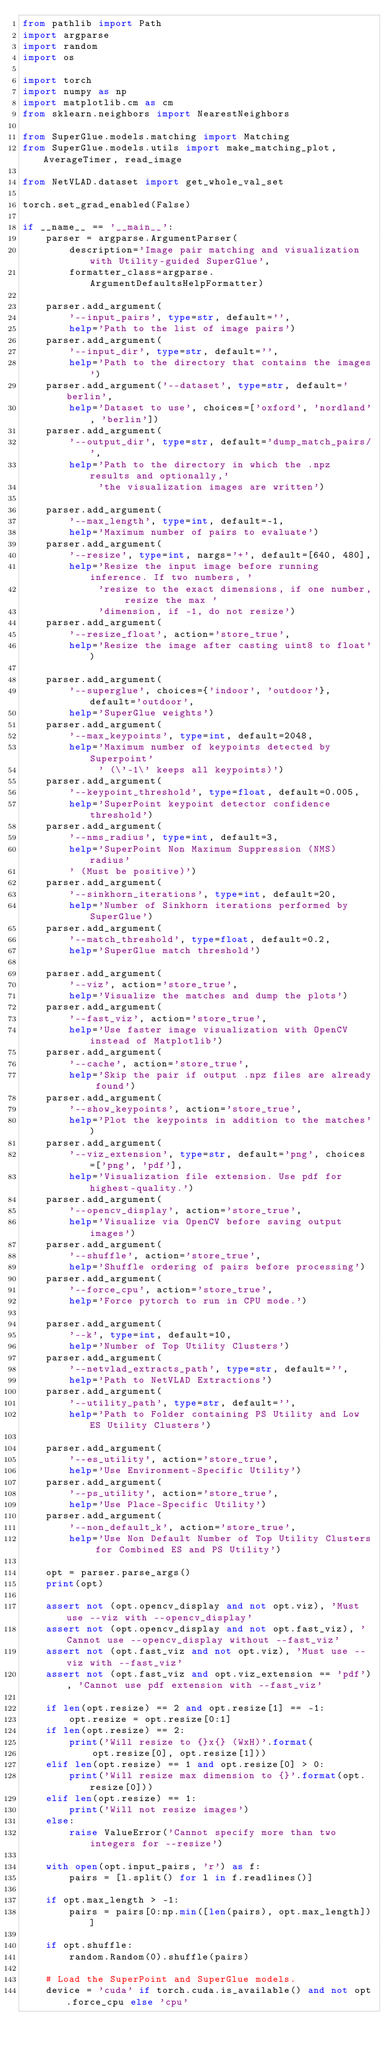Convert code to text. <code><loc_0><loc_0><loc_500><loc_500><_Python_>from pathlib import Path
import argparse
import random
import os

import torch
import numpy as np
import matplotlib.cm as cm
from sklearn.neighbors import NearestNeighbors

from SuperGlue.models.matching import Matching
from SuperGlue.models.utils import make_matching_plot, AverageTimer, read_image

from NetVLAD.dataset import get_whole_val_set

torch.set_grad_enabled(False)

if __name__ == '__main__':
    parser = argparse.ArgumentParser(
        description='Image pair matching and visualization with Utility-guided SuperGlue',
        formatter_class=argparse.ArgumentDefaultsHelpFormatter)

    parser.add_argument(
        '--input_pairs', type=str, default='',
        help='Path to the list of image pairs')
    parser.add_argument(
        '--input_dir', type=str, default='',
        help='Path to the directory that contains the images')
    parser.add_argument('--dataset', type=str, default='berlin', 
        help='Dataset to use', choices=['oxford', 'nordland', 'berlin'])
    parser.add_argument(
        '--output_dir', type=str, default='dump_match_pairs/',
        help='Path to the directory in which the .npz results and optionally,'
             'the visualization images are written')

    parser.add_argument(
        '--max_length', type=int, default=-1,
        help='Maximum number of pairs to evaluate')
    parser.add_argument(
        '--resize', type=int, nargs='+', default=[640, 480],
        help='Resize the input image before running inference. If two numbers, '
             'resize to the exact dimensions, if one number, resize the max '
             'dimension, if -1, do not resize')
    parser.add_argument(
        '--resize_float', action='store_true',
        help='Resize the image after casting uint8 to float')

    parser.add_argument(
        '--superglue', choices={'indoor', 'outdoor'}, default='outdoor',
        help='SuperGlue weights')
    parser.add_argument(
        '--max_keypoints', type=int, default=2048,
        help='Maximum number of keypoints detected by Superpoint'
             ' (\'-1\' keeps all keypoints)')
    parser.add_argument(
        '--keypoint_threshold', type=float, default=0.005,
        help='SuperPoint keypoint detector confidence threshold')
    parser.add_argument(
        '--nms_radius', type=int, default=3,
        help='SuperPoint Non Maximum Suppression (NMS) radius'
        ' (Must be positive)')
    parser.add_argument(
        '--sinkhorn_iterations', type=int, default=20,
        help='Number of Sinkhorn iterations performed by SuperGlue')
    parser.add_argument(
        '--match_threshold', type=float, default=0.2,
        help='SuperGlue match threshold')

    parser.add_argument(
        '--viz', action='store_true',
        help='Visualize the matches and dump the plots')
    parser.add_argument(
        '--fast_viz', action='store_true',
        help='Use faster image visualization with OpenCV instead of Matplotlib')
    parser.add_argument(
        '--cache', action='store_true',
        help='Skip the pair if output .npz files are already found')
    parser.add_argument(
        '--show_keypoints', action='store_true',
        help='Plot the keypoints in addition to the matches')
    parser.add_argument(
        '--viz_extension', type=str, default='png', choices=['png', 'pdf'],
        help='Visualization file extension. Use pdf for highest-quality.')
    parser.add_argument(
        '--opencv_display', action='store_true',
        help='Visualize via OpenCV before saving output images')
    parser.add_argument(
        '--shuffle', action='store_true',
        help='Shuffle ordering of pairs before processing')
    parser.add_argument(
        '--force_cpu', action='store_true',
        help='Force pytorch to run in CPU mode.')

    parser.add_argument(
        '--k', type=int, default=10,
        help='Number of Top Utility Clusters')
    parser.add_argument(
        '--netvlad_extracts_path', type=str, default='',
        help='Path to NetVLAD Extractions')
    parser.add_argument(
        '--utility_path', type=str, default='',
        help='Path to Folder containing PS Utility and Low ES Utility Clusters')

    parser.add_argument(
        '--es_utility', action='store_true',
        help='Use Environment-Specific Utility')
    parser.add_argument(
        '--ps_utility', action='store_true',
        help='Use Place-Specific Utility')
    parser.add_argument(
        '--non_default_k', action='store_true',
        help='Use Non Default Number of Top Utility Clusters for Combined ES and PS Utility')
    
    opt = parser.parse_args()
    print(opt)

    assert not (opt.opencv_display and not opt.viz), 'Must use --viz with --opencv_display'
    assert not (opt.opencv_display and not opt.fast_viz), 'Cannot use --opencv_display without --fast_viz'
    assert not (opt.fast_viz and not opt.viz), 'Must use --viz with --fast_viz'
    assert not (opt.fast_viz and opt.viz_extension == 'pdf'), 'Cannot use pdf extension with --fast_viz'

    if len(opt.resize) == 2 and opt.resize[1] == -1:
        opt.resize = opt.resize[0:1]
    if len(opt.resize) == 2:
        print('Will resize to {}x{} (WxH)'.format(
            opt.resize[0], opt.resize[1]))
    elif len(opt.resize) == 1 and opt.resize[0] > 0:
        print('Will resize max dimension to {}'.format(opt.resize[0]))
    elif len(opt.resize) == 1:
        print('Will not resize images')
    else:
        raise ValueError('Cannot specify more than two integers for --resize')

    with open(opt.input_pairs, 'r') as f:
        pairs = [l.split() for l in f.readlines()]

    if opt.max_length > -1:
        pairs = pairs[0:np.min([len(pairs), opt.max_length])]

    if opt.shuffle:
        random.Random(0).shuffle(pairs)

    # Load the SuperPoint and SuperGlue models.
    device = 'cuda' if torch.cuda.is_available() and not opt.force_cpu else 'cpu'</code> 